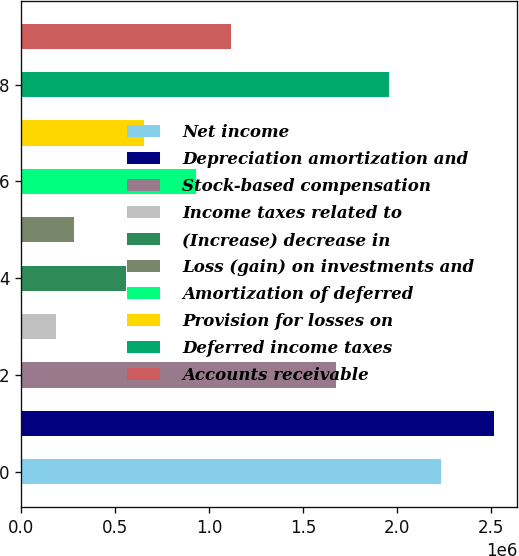Convert chart. <chart><loc_0><loc_0><loc_500><loc_500><bar_chart><fcel>Net income<fcel>Depreciation amortization and<fcel>Stock-based compensation<fcel>Income taxes related to<fcel>(Increase) decrease in<fcel>Loss (gain) on investments and<fcel>Amortization of deferred<fcel>Provision for losses on<fcel>Deferred income taxes<fcel>Accounts receivable<nl><fcel>2.23474e+06<fcel>2.51407e+06<fcel>1.67608e+06<fcel>186318<fcel>558759<fcel>279428<fcel>931199<fcel>651869<fcel>1.95541e+06<fcel>1.11742e+06<nl></chart> 